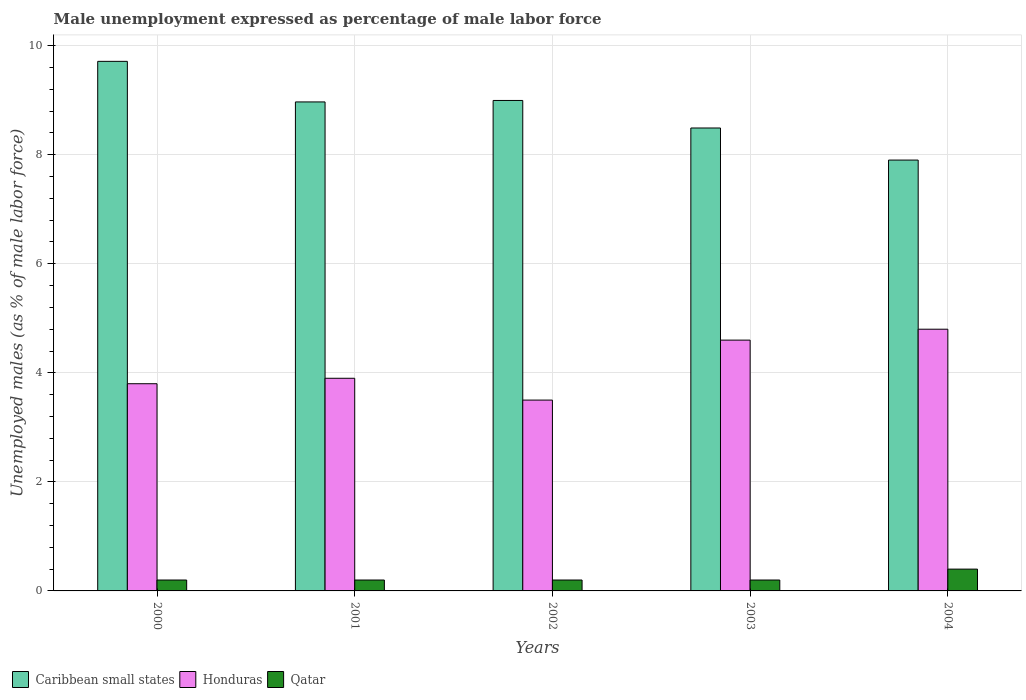How many groups of bars are there?
Offer a very short reply. 5. Are the number of bars per tick equal to the number of legend labels?
Your answer should be compact. Yes. How many bars are there on the 2nd tick from the left?
Ensure brevity in your answer.  3. How many bars are there on the 4th tick from the right?
Offer a terse response. 3. What is the unemployment in males in in Honduras in 2003?
Your answer should be compact. 4.6. Across all years, what is the maximum unemployment in males in in Qatar?
Your answer should be compact. 0.4. Across all years, what is the minimum unemployment in males in in Caribbean small states?
Ensure brevity in your answer.  7.9. What is the total unemployment in males in in Caribbean small states in the graph?
Make the answer very short. 44.07. What is the difference between the unemployment in males in in Qatar in 2000 and that in 2002?
Offer a terse response. 0. What is the difference between the unemployment in males in in Qatar in 2001 and the unemployment in males in in Honduras in 2002?
Make the answer very short. -3.3. What is the average unemployment in males in in Qatar per year?
Offer a terse response. 0.24. In the year 2001, what is the difference between the unemployment in males in in Honduras and unemployment in males in in Caribbean small states?
Your response must be concise. -5.07. In how many years, is the unemployment in males in in Qatar greater than 4 %?
Give a very brief answer. 0. Is the unemployment in males in in Honduras in 2000 less than that in 2004?
Give a very brief answer. Yes. What is the difference between the highest and the second highest unemployment in males in in Qatar?
Keep it short and to the point. 0.2. What is the difference between the highest and the lowest unemployment in males in in Honduras?
Provide a short and direct response. 1.3. In how many years, is the unemployment in males in in Qatar greater than the average unemployment in males in in Qatar taken over all years?
Your response must be concise. 1. Is the sum of the unemployment in males in in Caribbean small states in 2002 and 2004 greater than the maximum unemployment in males in in Qatar across all years?
Ensure brevity in your answer.  Yes. What does the 1st bar from the left in 2003 represents?
Your answer should be compact. Caribbean small states. What does the 1st bar from the right in 2002 represents?
Give a very brief answer. Qatar. Are all the bars in the graph horizontal?
Your answer should be compact. No. How many years are there in the graph?
Keep it short and to the point. 5. What is the difference between two consecutive major ticks on the Y-axis?
Offer a very short reply. 2. Does the graph contain any zero values?
Your answer should be compact. No. Does the graph contain grids?
Your response must be concise. Yes. Where does the legend appear in the graph?
Your answer should be very brief. Bottom left. How many legend labels are there?
Your answer should be very brief. 3. How are the legend labels stacked?
Your answer should be compact. Horizontal. What is the title of the graph?
Offer a very short reply. Male unemployment expressed as percentage of male labor force. Does "Cabo Verde" appear as one of the legend labels in the graph?
Your answer should be very brief. No. What is the label or title of the X-axis?
Ensure brevity in your answer.  Years. What is the label or title of the Y-axis?
Provide a short and direct response. Unemployed males (as % of male labor force). What is the Unemployed males (as % of male labor force) of Caribbean small states in 2000?
Offer a terse response. 9.71. What is the Unemployed males (as % of male labor force) of Honduras in 2000?
Provide a short and direct response. 3.8. What is the Unemployed males (as % of male labor force) in Qatar in 2000?
Keep it short and to the point. 0.2. What is the Unemployed males (as % of male labor force) in Caribbean small states in 2001?
Offer a terse response. 8.97. What is the Unemployed males (as % of male labor force) of Honduras in 2001?
Offer a very short reply. 3.9. What is the Unemployed males (as % of male labor force) of Qatar in 2001?
Your answer should be very brief. 0.2. What is the Unemployed males (as % of male labor force) in Caribbean small states in 2002?
Give a very brief answer. 9. What is the Unemployed males (as % of male labor force) of Qatar in 2002?
Make the answer very short. 0.2. What is the Unemployed males (as % of male labor force) in Caribbean small states in 2003?
Give a very brief answer. 8.49. What is the Unemployed males (as % of male labor force) in Honduras in 2003?
Your response must be concise. 4.6. What is the Unemployed males (as % of male labor force) in Qatar in 2003?
Give a very brief answer. 0.2. What is the Unemployed males (as % of male labor force) of Caribbean small states in 2004?
Your answer should be compact. 7.9. What is the Unemployed males (as % of male labor force) of Honduras in 2004?
Make the answer very short. 4.8. What is the Unemployed males (as % of male labor force) of Qatar in 2004?
Your answer should be very brief. 0.4. Across all years, what is the maximum Unemployed males (as % of male labor force) of Caribbean small states?
Your answer should be very brief. 9.71. Across all years, what is the maximum Unemployed males (as % of male labor force) of Honduras?
Your answer should be very brief. 4.8. Across all years, what is the maximum Unemployed males (as % of male labor force) in Qatar?
Keep it short and to the point. 0.4. Across all years, what is the minimum Unemployed males (as % of male labor force) of Caribbean small states?
Your answer should be very brief. 7.9. Across all years, what is the minimum Unemployed males (as % of male labor force) in Qatar?
Offer a terse response. 0.2. What is the total Unemployed males (as % of male labor force) in Caribbean small states in the graph?
Provide a succinct answer. 44.07. What is the total Unemployed males (as % of male labor force) in Honduras in the graph?
Offer a terse response. 20.6. What is the difference between the Unemployed males (as % of male labor force) of Caribbean small states in 2000 and that in 2001?
Offer a very short reply. 0.74. What is the difference between the Unemployed males (as % of male labor force) of Qatar in 2000 and that in 2001?
Provide a short and direct response. 0. What is the difference between the Unemployed males (as % of male labor force) of Caribbean small states in 2000 and that in 2002?
Offer a very short reply. 0.72. What is the difference between the Unemployed males (as % of male labor force) in Caribbean small states in 2000 and that in 2003?
Your response must be concise. 1.22. What is the difference between the Unemployed males (as % of male labor force) in Honduras in 2000 and that in 2003?
Offer a very short reply. -0.8. What is the difference between the Unemployed males (as % of male labor force) of Qatar in 2000 and that in 2003?
Ensure brevity in your answer.  0. What is the difference between the Unemployed males (as % of male labor force) in Caribbean small states in 2000 and that in 2004?
Make the answer very short. 1.81. What is the difference between the Unemployed males (as % of male labor force) of Honduras in 2000 and that in 2004?
Offer a terse response. -1. What is the difference between the Unemployed males (as % of male labor force) of Caribbean small states in 2001 and that in 2002?
Your answer should be compact. -0.03. What is the difference between the Unemployed males (as % of male labor force) in Caribbean small states in 2001 and that in 2003?
Your response must be concise. 0.48. What is the difference between the Unemployed males (as % of male labor force) in Honduras in 2001 and that in 2003?
Provide a short and direct response. -0.7. What is the difference between the Unemployed males (as % of male labor force) in Qatar in 2001 and that in 2003?
Provide a short and direct response. 0. What is the difference between the Unemployed males (as % of male labor force) of Caribbean small states in 2001 and that in 2004?
Ensure brevity in your answer.  1.07. What is the difference between the Unemployed males (as % of male labor force) of Qatar in 2001 and that in 2004?
Provide a succinct answer. -0.2. What is the difference between the Unemployed males (as % of male labor force) of Caribbean small states in 2002 and that in 2003?
Offer a very short reply. 0.5. What is the difference between the Unemployed males (as % of male labor force) in Honduras in 2002 and that in 2003?
Provide a succinct answer. -1.1. What is the difference between the Unemployed males (as % of male labor force) of Qatar in 2002 and that in 2003?
Your answer should be very brief. 0. What is the difference between the Unemployed males (as % of male labor force) in Caribbean small states in 2002 and that in 2004?
Offer a very short reply. 1.09. What is the difference between the Unemployed males (as % of male labor force) of Caribbean small states in 2003 and that in 2004?
Keep it short and to the point. 0.59. What is the difference between the Unemployed males (as % of male labor force) in Honduras in 2003 and that in 2004?
Ensure brevity in your answer.  -0.2. What is the difference between the Unemployed males (as % of male labor force) in Qatar in 2003 and that in 2004?
Ensure brevity in your answer.  -0.2. What is the difference between the Unemployed males (as % of male labor force) of Caribbean small states in 2000 and the Unemployed males (as % of male labor force) of Honduras in 2001?
Make the answer very short. 5.81. What is the difference between the Unemployed males (as % of male labor force) of Caribbean small states in 2000 and the Unemployed males (as % of male labor force) of Qatar in 2001?
Offer a very short reply. 9.51. What is the difference between the Unemployed males (as % of male labor force) of Caribbean small states in 2000 and the Unemployed males (as % of male labor force) of Honduras in 2002?
Provide a short and direct response. 6.21. What is the difference between the Unemployed males (as % of male labor force) in Caribbean small states in 2000 and the Unemployed males (as % of male labor force) in Qatar in 2002?
Keep it short and to the point. 9.51. What is the difference between the Unemployed males (as % of male labor force) in Caribbean small states in 2000 and the Unemployed males (as % of male labor force) in Honduras in 2003?
Ensure brevity in your answer.  5.11. What is the difference between the Unemployed males (as % of male labor force) of Caribbean small states in 2000 and the Unemployed males (as % of male labor force) of Qatar in 2003?
Provide a succinct answer. 9.51. What is the difference between the Unemployed males (as % of male labor force) in Caribbean small states in 2000 and the Unemployed males (as % of male labor force) in Honduras in 2004?
Keep it short and to the point. 4.91. What is the difference between the Unemployed males (as % of male labor force) of Caribbean small states in 2000 and the Unemployed males (as % of male labor force) of Qatar in 2004?
Your answer should be compact. 9.31. What is the difference between the Unemployed males (as % of male labor force) of Caribbean small states in 2001 and the Unemployed males (as % of male labor force) of Honduras in 2002?
Provide a succinct answer. 5.47. What is the difference between the Unemployed males (as % of male labor force) of Caribbean small states in 2001 and the Unemployed males (as % of male labor force) of Qatar in 2002?
Offer a terse response. 8.77. What is the difference between the Unemployed males (as % of male labor force) in Caribbean small states in 2001 and the Unemployed males (as % of male labor force) in Honduras in 2003?
Make the answer very short. 4.37. What is the difference between the Unemployed males (as % of male labor force) in Caribbean small states in 2001 and the Unemployed males (as % of male labor force) in Qatar in 2003?
Keep it short and to the point. 8.77. What is the difference between the Unemployed males (as % of male labor force) of Honduras in 2001 and the Unemployed males (as % of male labor force) of Qatar in 2003?
Your answer should be compact. 3.7. What is the difference between the Unemployed males (as % of male labor force) of Caribbean small states in 2001 and the Unemployed males (as % of male labor force) of Honduras in 2004?
Make the answer very short. 4.17. What is the difference between the Unemployed males (as % of male labor force) of Caribbean small states in 2001 and the Unemployed males (as % of male labor force) of Qatar in 2004?
Make the answer very short. 8.57. What is the difference between the Unemployed males (as % of male labor force) of Honduras in 2001 and the Unemployed males (as % of male labor force) of Qatar in 2004?
Provide a short and direct response. 3.5. What is the difference between the Unemployed males (as % of male labor force) of Caribbean small states in 2002 and the Unemployed males (as % of male labor force) of Honduras in 2003?
Your answer should be very brief. 4.4. What is the difference between the Unemployed males (as % of male labor force) of Caribbean small states in 2002 and the Unemployed males (as % of male labor force) of Qatar in 2003?
Keep it short and to the point. 8.8. What is the difference between the Unemployed males (as % of male labor force) in Caribbean small states in 2002 and the Unemployed males (as % of male labor force) in Honduras in 2004?
Your answer should be compact. 4.2. What is the difference between the Unemployed males (as % of male labor force) in Caribbean small states in 2002 and the Unemployed males (as % of male labor force) in Qatar in 2004?
Offer a terse response. 8.6. What is the difference between the Unemployed males (as % of male labor force) in Caribbean small states in 2003 and the Unemployed males (as % of male labor force) in Honduras in 2004?
Your response must be concise. 3.69. What is the difference between the Unemployed males (as % of male labor force) of Caribbean small states in 2003 and the Unemployed males (as % of male labor force) of Qatar in 2004?
Keep it short and to the point. 8.09. What is the average Unemployed males (as % of male labor force) in Caribbean small states per year?
Provide a succinct answer. 8.81. What is the average Unemployed males (as % of male labor force) in Honduras per year?
Offer a very short reply. 4.12. What is the average Unemployed males (as % of male labor force) of Qatar per year?
Your response must be concise. 0.24. In the year 2000, what is the difference between the Unemployed males (as % of male labor force) in Caribbean small states and Unemployed males (as % of male labor force) in Honduras?
Offer a very short reply. 5.91. In the year 2000, what is the difference between the Unemployed males (as % of male labor force) in Caribbean small states and Unemployed males (as % of male labor force) in Qatar?
Your response must be concise. 9.51. In the year 2001, what is the difference between the Unemployed males (as % of male labor force) of Caribbean small states and Unemployed males (as % of male labor force) of Honduras?
Keep it short and to the point. 5.07. In the year 2001, what is the difference between the Unemployed males (as % of male labor force) in Caribbean small states and Unemployed males (as % of male labor force) in Qatar?
Provide a succinct answer. 8.77. In the year 2001, what is the difference between the Unemployed males (as % of male labor force) of Honduras and Unemployed males (as % of male labor force) of Qatar?
Your answer should be very brief. 3.7. In the year 2002, what is the difference between the Unemployed males (as % of male labor force) in Caribbean small states and Unemployed males (as % of male labor force) in Honduras?
Make the answer very short. 5.5. In the year 2002, what is the difference between the Unemployed males (as % of male labor force) of Caribbean small states and Unemployed males (as % of male labor force) of Qatar?
Keep it short and to the point. 8.8. In the year 2003, what is the difference between the Unemployed males (as % of male labor force) of Caribbean small states and Unemployed males (as % of male labor force) of Honduras?
Your answer should be compact. 3.89. In the year 2003, what is the difference between the Unemployed males (as % of male labor force) of Caribbean small states and Unemployed males (as % of male labor force) of Qatar?
Provide a short and direct response. 8.29. In the year 2004, what is the difference between the Unemployed males (as % of male labor force) of Caribbean small states and Unemployed males (as % of male labor force) of Honduras?
Provide a short and direct response. 3.1. In the year 2004, what is the difference between the Unemployed males (as % of male labor force) in Caribbean small states and Unemployed males (as % of male labor force) in Qatar?
Give a very brief answer. 7.5. In the year 2004, what is the difference between the Unemployed males (as % of male labor force) in Honduras and Unemployed males (as % of male labor force) in Qatar?
Ensure brevity in your answer.  4.4. What is the ratio of the Unemployed males (as % of male labor force) in Caribbean small states in 2000 to that in 2001?
Your response must be concise. 1.08. What is the ratio of the Unemployed males (as % of male labor force) in Honduras in 2000 to that in 2001?
Keep it short and to the point. 0.97. What is the ratio of the Unemployed males (as % of male labor force) in Qatar in 2000 to that in 2001?
Provide a succinct answer. 1. What is the ratio of the Unemployed males (as % of male labor force) of Caribbean small states in 2000 to that in 2002?
Keep it short and to the point. 1.08. What is the ratio of the Unemployed males (as % of male labor force) of Honduras in 2000 to that in 2002?
Make the answer very short. 1.09. What is the ratio of the Unemployed males (as % of male labor force) in Qatar in 2000 to that in 2002?
Give a very brief answer. 1. What is the ratio of the Unemployed males (as % of male labor force) in Caribbean small states in 2000 to that in 2003?
Your response must be concise. 1.14. What is the ratio of the Unemployed males (as % of male labor force) of Honduras in 2000 to that in 2003?
Your answer should be very brief. 0.83. What is the ratio of the Unemployed males (as % of male labor force) in Qatar in 2000 to that in 2003?
Your answer should be compact. 1. What is the ratio of the Unemployed males (as % of male labor force) of Caribbean small states in 2000 to that in 2004?
Provide a short and direct response. 1.23. What is the ratio of the Unemployed males (as % of male labor force) in Honduras in 2000 to that in 2004?
Make the answer very short. 0.79. What is the ratio of the Unemployed males (as % of male labor force) in Caribbean small states in 2001 to that in 2002?
Provide a succinct answer. 1. What is the ratio of the Unemployed males (as % of male labor force) of Honduras in 2001 to that in 2002?
Keep it short and to the point. 1.11. What is the ratio of the Unemployed males (as % of male labor force) of Caribbean small states in 2001 to that in 2003?
Make the answer very short. 1.06. What is the ratio of the Unemployed males (as % of male labor force) in Honduras in 2001 to that in 2003?
Give a very brief answer. 0.85. What is the ratio of the Unemployed males (as % of male labor force) in Qatar in 2001 to that in 2003?
Make the answer very short. 1. What is the ratio of the Unemployed males (as % of male labor force) in Caribbean small states in 2001 to that in 2004?
Provide a short and direct response. 1.14. What is the ratio of the Unemployed males (as % of male labor force) of Honduras in 2001 to that in 2004?
Keep it short and to the point. 0.81. What is the ratio of the Unemployed males (as % of male labor force) in Caribbean small states in 2002 to that in 2003?
Give a very brief answer. 1.06. What is the ratio of the Unemployed males (as % of male labor force) of Honduras in 2002 to that in 2003?
Make the answer very short. 0.76. What is the ratio of the Unemployed males (as % of male labor force) in Qatar in 2002 to that in 2003?
Keep it short and to the point. 1. What is the ratio of the Unemployed males (as % of male labor force) in Caribbean small states in 2002 to that in 2004?
Your response must be concise. 1.14. What is the ratio of the Unemployed males (as % of male labor force) in Honduras in 2002 to that in 2004?
Your answer should be compact. 0.73. What is the ratio of the Unemployed males (as % of male labor force) of Caribbean small states in 2003 to that in 2004?
Your response must be concise. 1.07. What is the ratio of the Unemployed males (as % of male labor force) of Honduras in 2003 to that in 2004?
Offer a very short reply. 0.96. What is the difference between the highest and the second highest Unemployed males (as % of male labor force) in Caribbean small states?
Provide a succinct answer. 0.72. What is the difference between the highest and the second highest Unemployed males (as % of male labor force) in Honduras?
Your answer should be compact. 0.2. What is the difference between the highest and the second highest Unemployed males (as % of male labor force) of Qatar?
Offer a very short reply. 0.2. What is the difference between the highest and the lowest Unemployed males (as % of male labor force) of Caribbean small states?
Keep it short and to the point. 1.81. What is the difference between the highest and the lowest Unemployed males (as % of male labor force) of Honduras?
Your answer should be very brief. 1.3. 